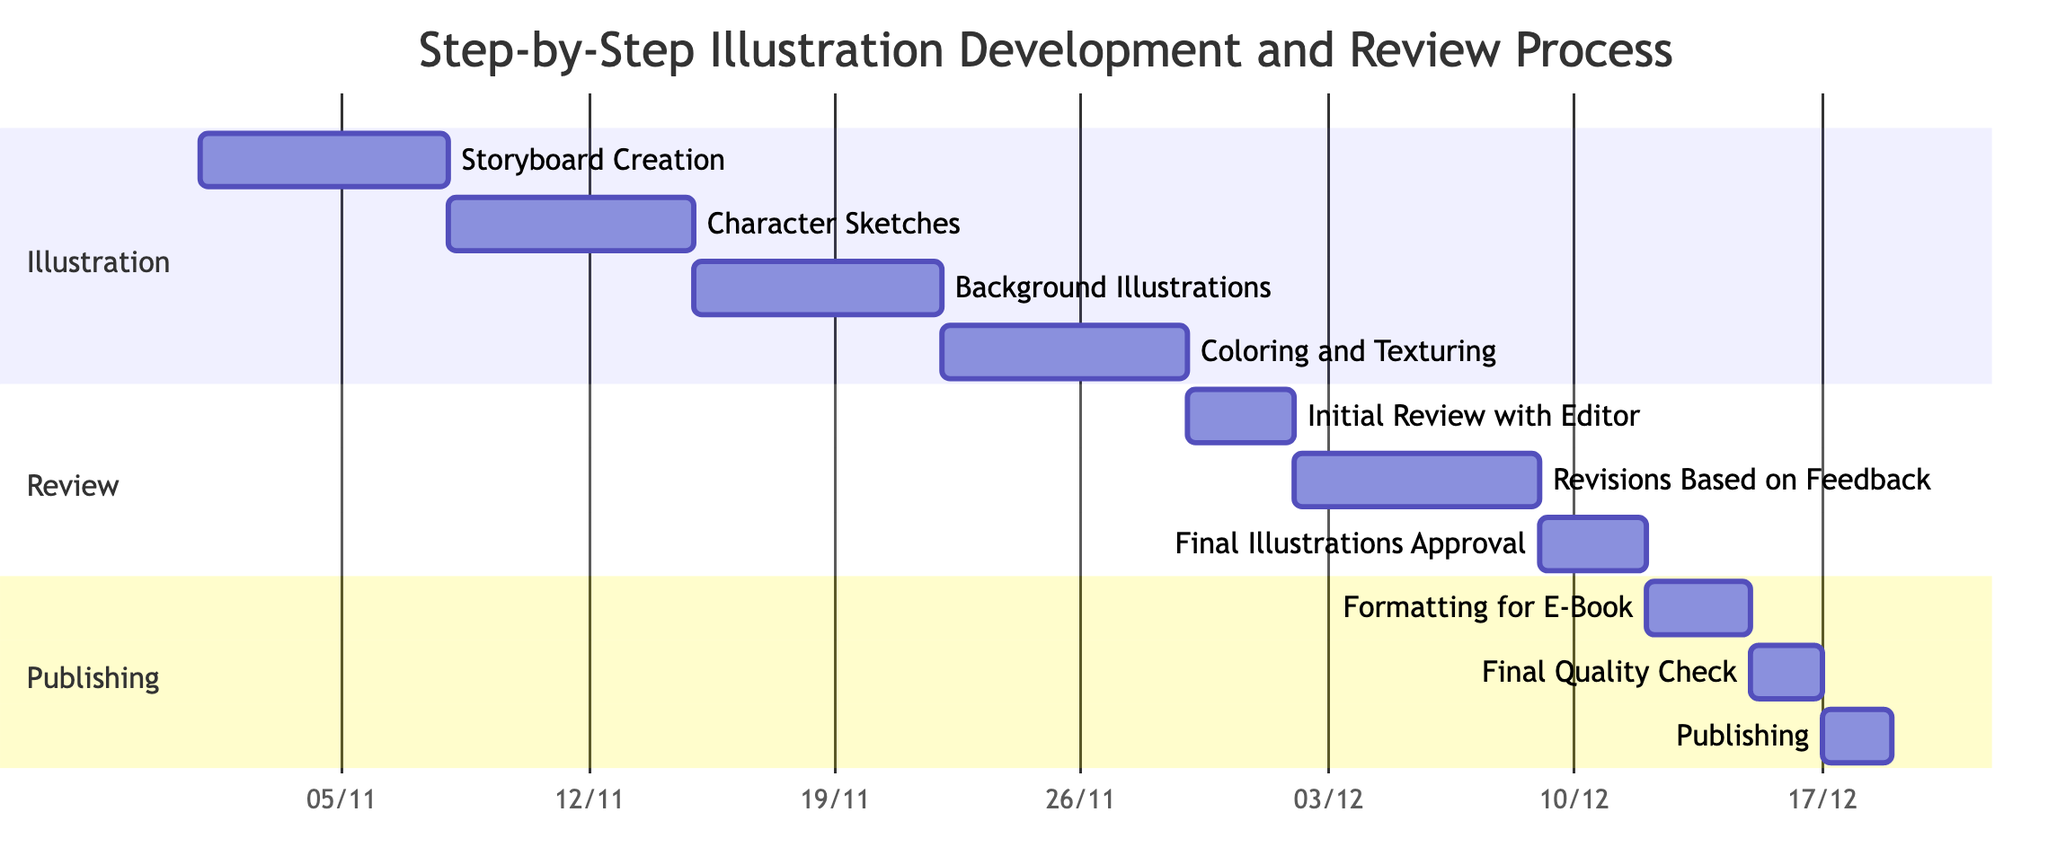What is the duration of Storyboard Creation? The duration for Storyboard Creation is given as 7 days, starting from November 1, 2023, to November 7, 2023.
Answer: 7 days What task follows Character Sketches? Character Sketches is followed by Background Illustrations, which starts after Character Sketches is completed.
Answer: Background Illustrations How many tasks are in the Review section? The Review section contains three tasks: Initial Review with Editor, Revisions Based on Feedback, and Final Illustrations Approval.
Answer: 3 tasks When does the Final Quality Check start? Final Quality Check starts after Formatting for E-Book is completed on December 14, 2023, so it starts on December 15, 2023.
Answer: December 15, 2023 Which task ends immediately before Publishing? The task that ends immediately before Publishing is Final Quality Check, which concludes on December 16, 2023, before Publishing starts.
Answer: Final Quality Check What is the start date of Revisions Based on Feedback? Revisions Based on Feedback starts on December 2, 2023, which is after the Initial Review with Editor is completed.
Answer: December 2, 2023 Which task has the earliest start date? The earliest task in the diagram is Storyboard Creation, which starts on November 1, 2023.
Answer: Storyboard Creation How many days are allocated for Formatting for E-Book? Formatting for E-Book is allocated 3 days, starting from December 12, 2023, to December 14, 2023.
Answer: 3 days What is the relationship between Coloring and Texturing and Initial Review with Editor? Coloring and Texturing must be completed before Initial Review with Editor can begin, as it is a dependency.
Answer: Dependency 